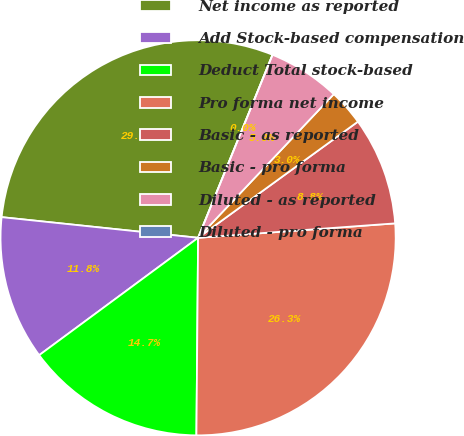Convert chart to OTSL. <chart><loc_0><loc_0><loc_500><loc_500><pie_chart><fcel>Net income as reported<fcel>Add Stock-based compensation<fcel>Deduct Total stock-based<fcel>Pro forma net income<fcel>Basic - as reported<fcel>Basic - pro forma<fcel>Diluted - as reported<fcel>Diluted - pro forma<nl><fcel>29.48%<fcel>11.79%<fcel>14.74%<fcel>26.3%<fcel>8.84%<fcel>2.95%<fcel>5.9%<fcel>0.0%<nl></chart> 